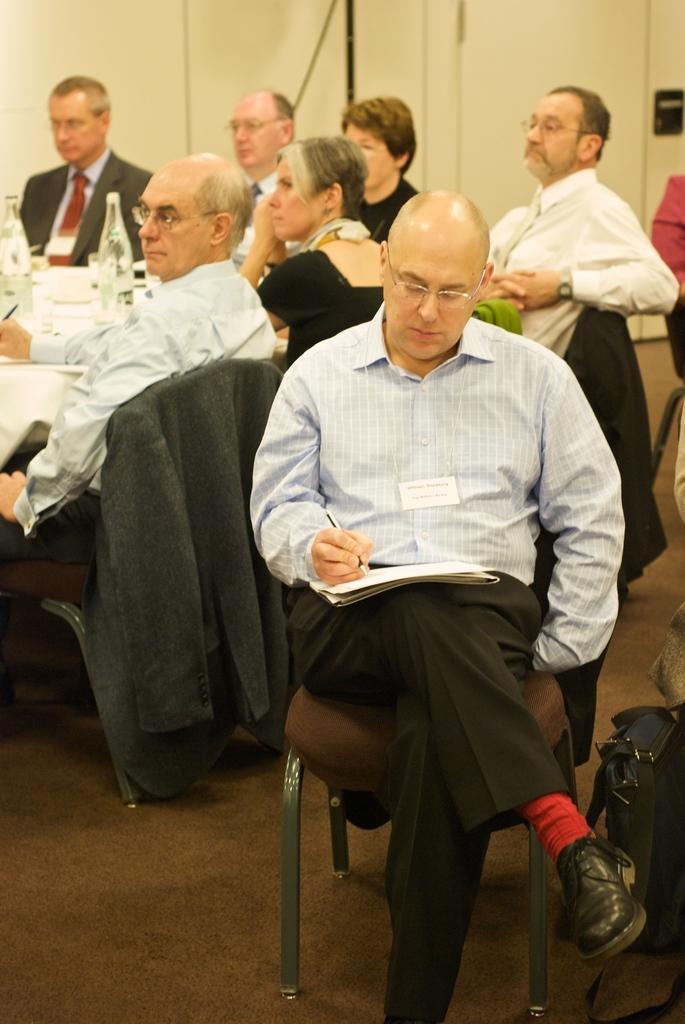Please provide a concise description of this image. In this image there is a group of person who are sitting around the table. on the table there are two bottles, plates and is covered by a cloth. This person who is sitting on the chair is writing something on a book with a black pen. On the bottom right corner there is a black bag. 